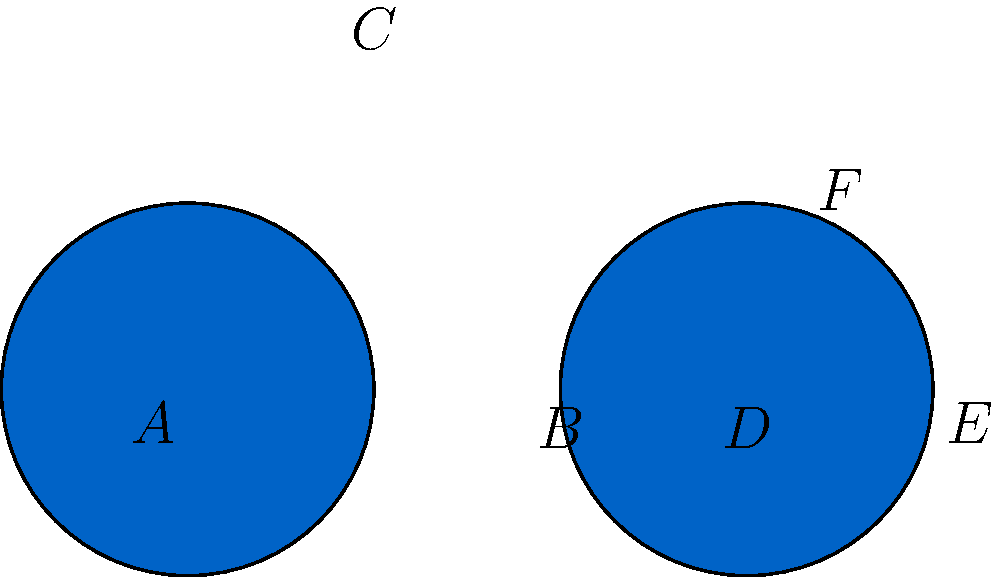In preparation for your Olympic-themed event, you're analyzing the iconic Olympic rings. Two adjacent rings are shown above, each with a radius of 1 unit. If the distance between their centers is 3 units, what is the area of the overlapping region between these two rings? Let's approach this step-by-step:

1) First, we need to recognize that the overlapping region forms a lens shape.

2) The area of this lens can be calculated using the formula:
   $$A = 2r^2 \arccos(\frac{d}{2r}) - d\sqrt{r^2 - (\frac{d}{2})^2}$$
   where $r$ is the radius of each circle and $d$ is the distance between their centers.

3) We're given that $r = 1$ and $d = 3$. Let's substitute these values:
   $$A = 2(1^2) \arccos(\frac{3}{2(1)}) - 3\sqrt{1^2 - (\frac{3}{2})^2}$$

4) Simplify:
   $$A = 2 \arccos(\frac{3}{2}) - 3\sqrt{1 - \frac{9}{4}}$$

5) $$A = 2 \arccos(\frac{3}{2}) - 3\sqrt{-\frac{5}{4}}$$

6) Since the square root of a negative number is undefined in real numbers, this means there is no overlap between the circles.

7) This makes sense geometrically: if the distance between the centers (3) is greater than the sum of the radii (1 + 1 = 2), the circles do not intersect.
Answer: 0 